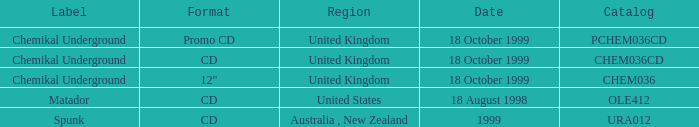What label is associated with the United Kingdom and the chem036 catalog? Chemikal Underground. 